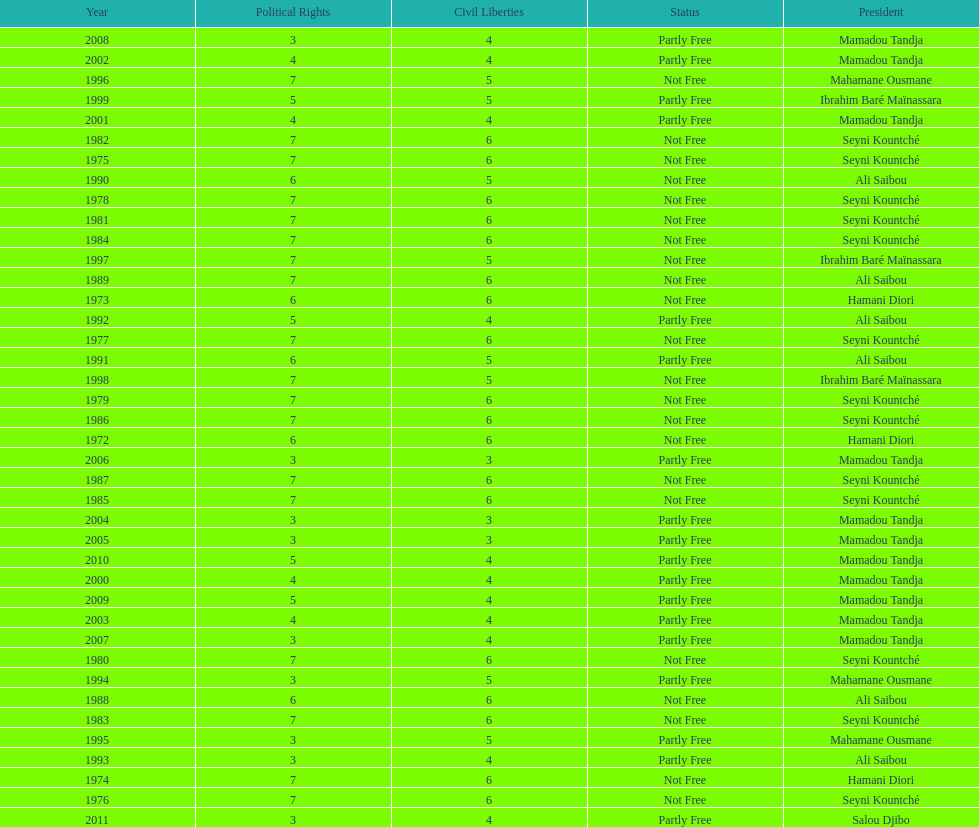What is the number of time seyni kountche has been president? 13. 